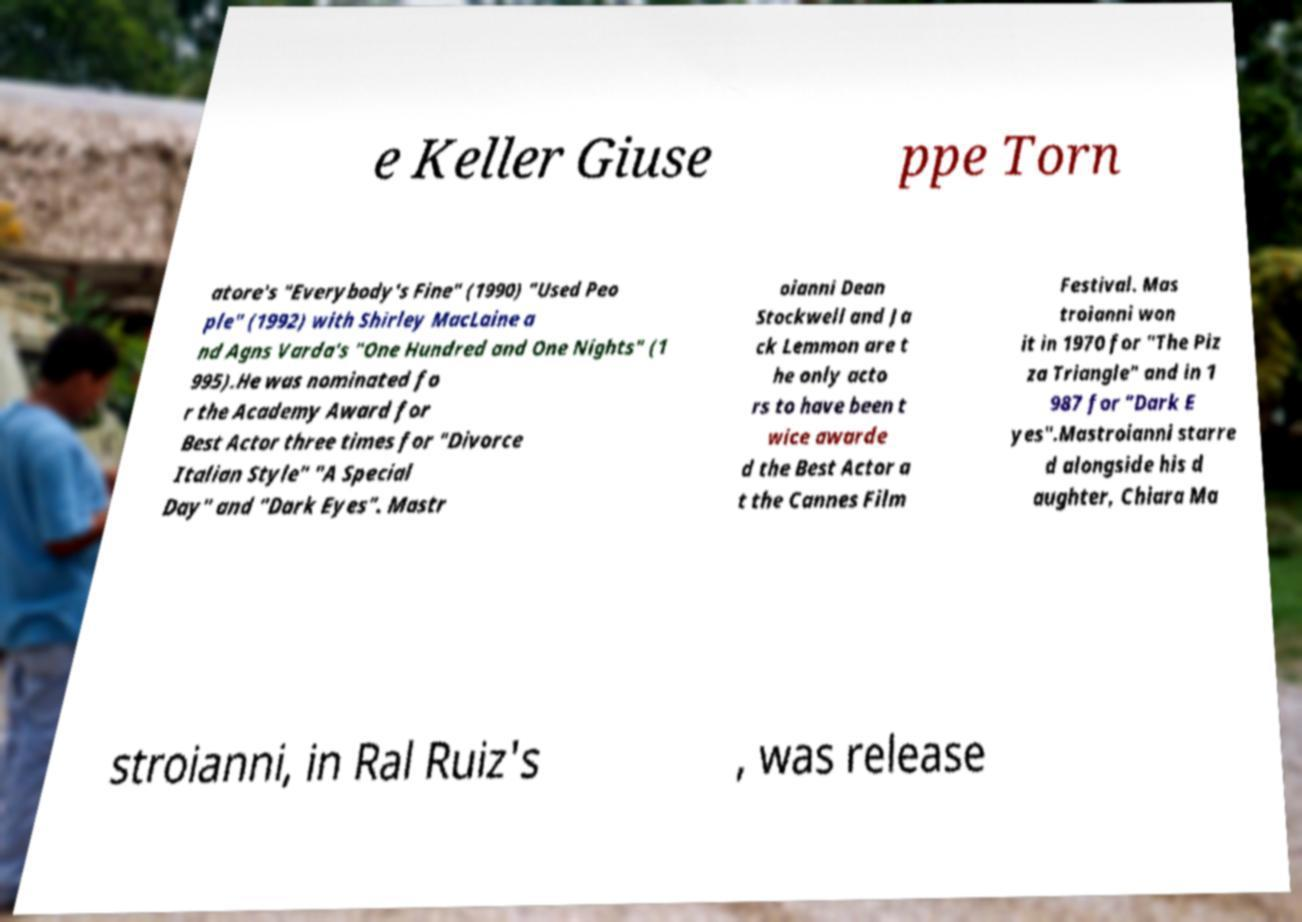Please identify and transcribe the text found in this image. e Keller Giuse ppe Torn atore's "Everybody's Fine" (1990) "Used Peo ple" (1992) with Shirley MacLaine a nd Agns Varda's "One Hundred and One Nights" (1 995).He was nominated fo r the Academy Award for Best Actor three times for "Divorce Italian Style" "A Special Day" and "Dark Eyes". Mastr oianni Dean Stockwell and Ja ck Lemmon are t he only acto rs to have been t wice awarde d the Best Actor a t the Cannes Film Festival. Mas troianni won it in 1970 for "The Piz za Triangle" and in 1 987 for "Dark E yes".Mastroianni starre d alongside his d aughter, Chiara Ma stroianni, in Ral Ruiz's , was release 